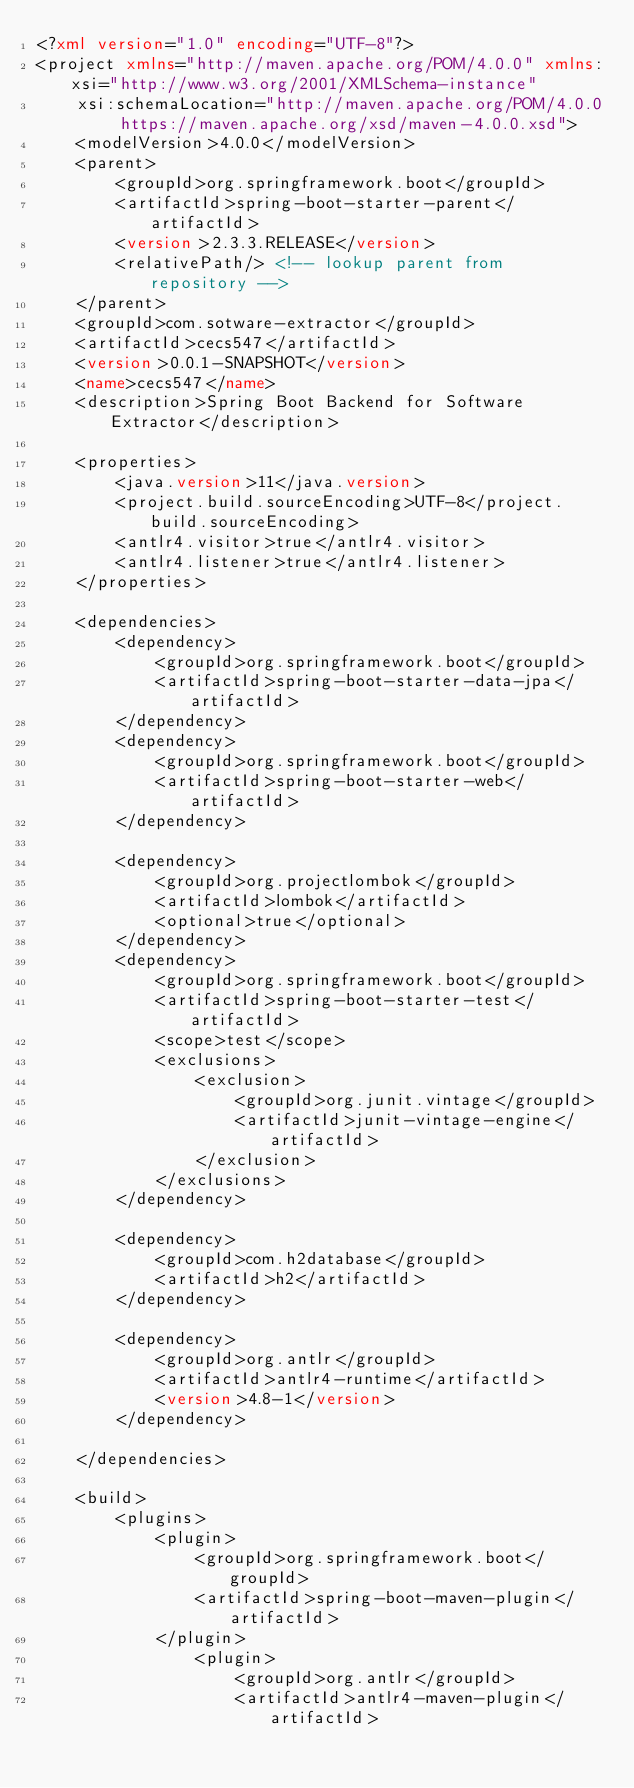Convert code to text. <code><loc_0><loc_0><loc_500><loc_500><_XML_><?xml version="1.0" encoding="UTF-8"?>
<project xmlns="http://maven.apache.org/POM/4.0.0" xmlns:xsi="http://www.w3.org/2001/XMLSchema-instance"
	xsi:schemaLocation="http://maven.apache.org/POM/4.0.0 https://maven.apache.org/xsd/maven-4.0.0.xsd">
	<modelVersion>4.0.0</modelVersion>
	<parent>
		<groupId>org.springframework.boot</groupId>
		<artifactId>spring-boot-starter-parent</artifactId>
		<version>2.3.3.RELEASE</version>
		<relativePath/> <!-- lookup parent from repository -->
	</parent>
	<groupId>com.sotware-extractor</groupId>
	<artifactId>cecs547</artifactId>
	<version>0.0.1-SNAPSHOT</version>
	<name>cecs547</name>
	<description>Spring Boot Backend for Software Extractor</description>

	<properties>
		<java.version>11</java.version>
		<project.build.sourceEncoding>UTF-8</project.build.sourceEncoding>
		<antlr4.visitor>true</antlr4.visitor>
		<antlr4.listener>true</antlr4.listener>
	</properties>

	<dependencies>
		<dependency>
			<groupId>org.springframework.boot</groupId>
			<artifactId>spring-boot-starter-data-jpa</artifactId>
		</dependency>
		<dependency>
			<groupId>org.springframework.boot</groupId>
			<artifactId>spring-boot-starter-web</artifactId>
		</dependency>

		<dependency>
			<groupId>org.projectlombok</groupId>
			<artifactId>lombok</artifactId>
			<optional>true</optional>
		</dependency>
		<dependency>
			<groupId>org.springframework.boot</groupId>
			<artifactId>spring-boot-starter-test</artifactId>
			<scope>test</scope>
			<exclusions>
				<exclusion>
					<groupId>org.junit.vintage</groupId>
					<artifactId>junit-vintage-engine</artifactId>
				</exclusion>
			</exclusions>
		</dependency>

		<dependency>
			<groupId>com.h2database</groupId>
			<artifactId>h2</artifactId>
		</dependency>

		<dependency>
			<groupId>org.antlr</groupId>
			<artifactId>antlr4-runtime</artifactId>
			<version>4.8-1</version>
		</dependency>

	</dependencies>

	<build>
		<plugins>
			<plugin>
				<groupId>org.springframework.boot</groupId>
				<artifactId>spring-boot-maven-plugin</artifactId>
			</plugin>
				<plugin>
					<groupId>org.antlr</groupId>
					<artifactId>antlr4-maven-plugin</artifactId></code> 